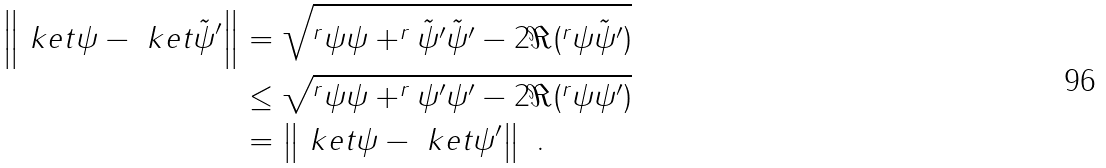<formula> <loc_0><loc_0><loc_500><loc_500>\left \| \ k e t { \psi } - \ k e t { \tilde { \psi } ^ { \prime } } \right \| & = \sqrt { ^ { r } { \psi } { \psi } + ^ { r } { \tilde { \psi } ^ { \prime } } { \tilde { \psi } ^ { \prime } } - 2 \Re ( ^ { r } { \psi } { \tilde { \psi } ^ { \prime } } ) } \\ & \leq \sqrt { ^ { r } { \psi } { \psi } + ^ { r } { \psi ^ { \prime } } { \psi ^ { \prime } } - 2 \Re ( ^ { r } { \psi } { \psi ^ { \prime } } ) } \\ & = \left \| \ k e t { \psi } - \ k e t { \psi ^ { \prime } } \right \| \ .</formula> 